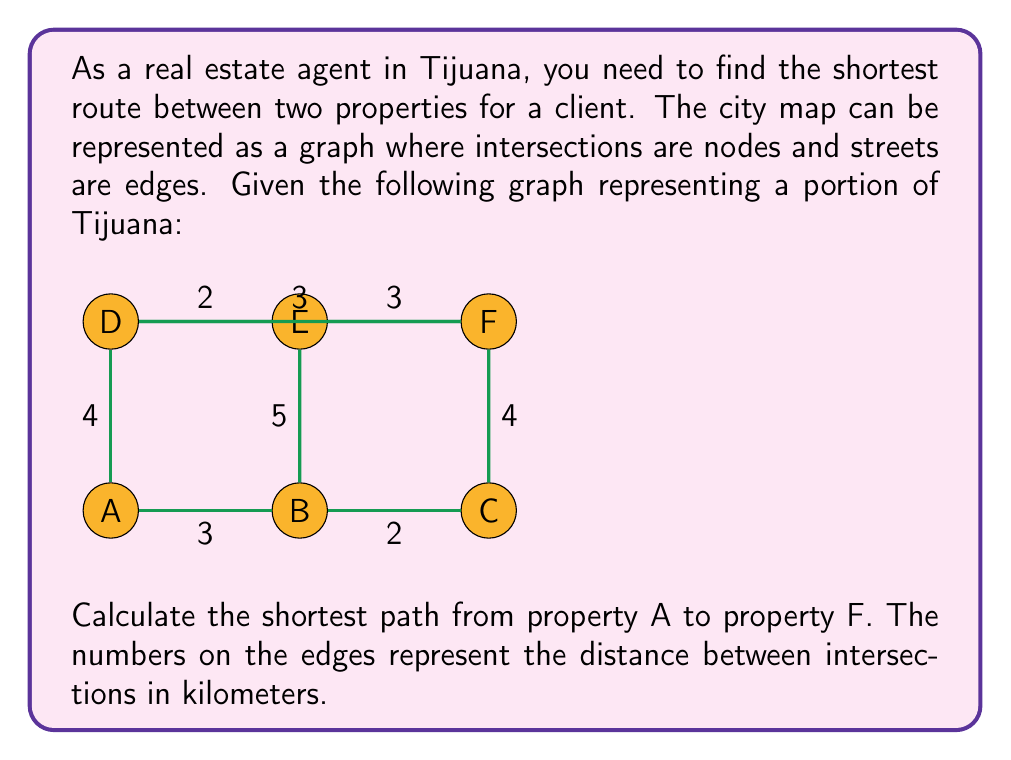Show me your answer to this math problem. To solve this problem, we can use Dijkstra's algorithm, which is an efficient method for finding the shortest path between nodes in a graph.

Step 1: Initialize distances
Set the distance to A as 0 and all other nodes as infinity.
$$ d(A) = 0, d(B) = d(C) = d(D) = d(E) = d(F) = \infty $$

Step 2: Visit node A
Update distances to neighboring nodes:
$$ d(B) = 3, d(D) = 4 $$

Step 3: Visit node B (closest unvisited node)
Update distances:
$$ d(C) = 3 + 2 = 5, d(E) = 3 + 5 = 8 $$

Step 4: Visit node D
Update distances:
$$ d(E) = \min(8, 4 + 2) = 6, d(F) = 4 + 3 = 7 $$

Step 5: Visit node C
No updates needed.

Step 6: Visit node F
No updates needed.

The shortest path from A to F is A → D → F, with a total distance of 7 km.
Answer: The shortest path from property A to property F is 7 km, following the route A → D → F. 